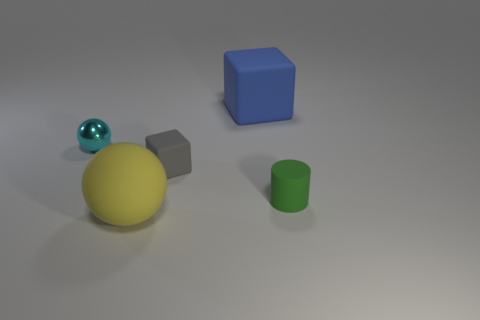Does the ball on the right side of the cyan shiny ball have the same size as the small gray object?
Make the answer very short. No. The small thing on the right side of the rubber cube that is on the right side of the small matte object that is left of the green cylinder is made of what material?
Keep it short and to the point. Rubber. There is a big matte thing that is behind the green rubber cylinder; is it the same color as the small object to the right of the big blue rubber block?
Give a very brief answer. No. The sphere that is behind the small cylinder in front of the gray thing is made of what material?
Make the answer very short. Metal. The other rubber object that is the same size as the yellow object is what color?
Give a very brief answer. Blue. There is a yellow rubber object; does it have the same shape as the large object that is behind the large matte sphere?
Your answer should be compact. No. There is a small green rubber object that is in front of the object that is behind the small sphere; how many tiny gray rubber blocks are left of it?
Your answer should be compact. 1. There is a block that is in front of the big rubber thing behind the large yellow matte ball; how big is it?
Your answer should be compact. Small. What size is the yellow thing that is made of the same material as the cylinder?
Offer a very short reply. Large. There is a rubber thing that is on the left side of the blue matte thing and behind the rubber ball; what shape is it?
Offer a very short reply. Cube. 